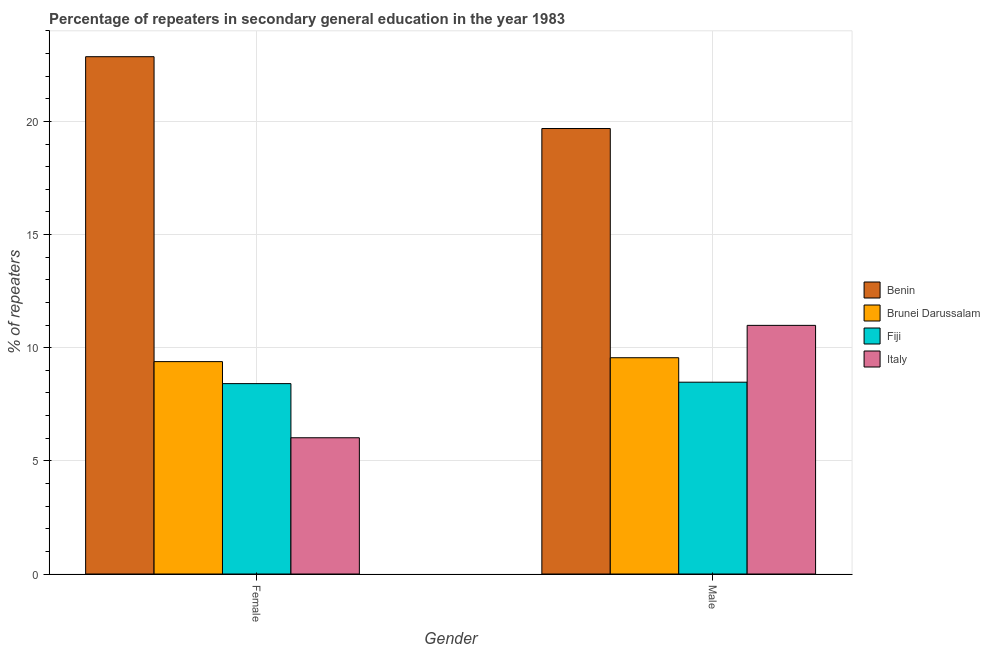Are the number of bars on each tick of the X-axis equal?
Provide a succinct answer. Yes. How many bars are there on the 1st tick from the right?
Ensure brevity in your answer.  4. What is the percentage of female repeaters in Brunei Darussalam?
Your answer should be compact. 9.38. Across all countries, what is the maximum percentage of female repeaters?
Your answer should be very brief. 22.86. Across all countries, what is the minimum percentage of male repeaters?
Offer a very short reply. 8.48. In which country was the percentage of male repeaters maximum?
Ensure brevity in your answer.  Benin. What is the total percentage of male repeaters in the graph?
Offer a terse response. 48.7. What is the difference between the percentage of male repeaters in Fiji and that in Benin?
Ensure brevity in your answer.  -11.21. What is the difference between the percentage of female repeaters in Benin and the percentage of male repeaters in Italy?
Keep it short and to the point. 11.87. What is the average percentage of female repeaters per country?
Make the answer very short. 11.67. What is the difference between the percentage of male repeaters and percentage of female repeaters in Fiji?
Offer a very short reply. 0.06. What is the ratio of the percentage of male repeaters in Benin to that in Brunei Darussalam?
Keep it short and to the point. 2.06. Is the percentage of male repeaters in Brunei Darussalam less than that in Italy?
Make the answer very short. Yes. What does the 1st bar from the left in Female represents?
Your answer should be compact. Benin. What does the 1st bar from the right in Female represents?
Give a very brief answer. Italy. Are all the bars in the graph horizontal?
Your answer should be very brief. No. Are the values on the major ticks of Y-axis written in scientific E-notation?
Provide a short and direct response. No. Where does the legend appear in the graph?
Provide a short and direct response. Center right. What is the title of the graph?
Provide a short and direct response. Percentage of repeaters in secondary general education in the year 1983. What is the label or title of the Y-axis?
Offer a very short reply. % of repeaters. What is the % of repeaters of Benin in Female?
Your response must be concise. 22.86. What is the % of repeaters of Brunei Darussalam in Female?
Keep it short and to the point. 9.38. What is the % of repeaters in Fiji in Female?
Offer a terse response. 8.41. What is the % of repeaters of Italy in Female?
Provide a succinct answer. 6.02. What is the % of repeaters of Benin in Male?
Give a very brief answer. 19.68. What is the % of repeaters in Brunei Darussalam in Male?
Your answer should be very brief. 9.56. What is the % of repeaters of Fiji in Male?
Make the answer very short. 8.48. What is the % of repeaters of Italy in Male?
Ensure brevity in your answer.  10.99. Across all Gender, what is the maximum % of repeaters in Benin?
Offer a very short reply. 22.86. Across all Gender, what is the maximum % of repeaters in Brunei Darussalam?
Ensure brevity in your answer.  9.56. Across all Gender, what is the maximum % of repeaters of Fiji?
Ensure brevity in your answer.  8.48. Across all Gender, what is the maximum % of repeaters in Italy?
Ensure brevity in your answer.  10.99. Across all Gender, what is the minimum % of repeaters in Benin?
Keep it short and to the point. 19.68. Across all Gender, what is the minimum % of repeaters in Brunei Darussalam?
Provide a short and direct response. 9.38. Across all Gender, what is the minimum % of repeaters in Fiji?
Your answer should be compact. 8.41. Across all Gender, what is the minimum % of repeaters of Italy?
Provide a succinct answer. 6.02. What is the total % of repeaters of Benin in the graph?
Keep it short and to the point. 42.54. What is the total % of repeaters of Brunei Darussalam in the graph?
Make the answer very short. 18.94. What is the total % of repeaters of Fiji in the graph?
Your answer should be compact. 16.89. What is the total % of repeaters of Italy in the graph?
Your response must be concise. 17.01. What is the difference between the % of repeaters in Benin in Female and that in Male?
Your response must be concise. 3.17. What is the difference between the % of repeaters in Brunei Darussalam in Female and that in Male?
Your answer should be very brief. -0.17. What is the difference between the % of repeaters in Fiji in Female and that in Male?
Your response must be concise. -0.06. What is the difference between the % of repeaters of Italy in Female and that in Male?
Offer a very short reply. -4.97. What is the difference between the % of repeaters in Benin in Female and the % of repeaters in Brunei Darussalam in Male?
Offer a terse response. 13.3. What is the difference between the % of repeaters in Benin in Female and the % of repeaters in Fiji in Male?
Make the answer very short. 14.38. What is the difference between the % of repeaters of Benin in Female and the % of repeaters of Italy in Male?
Make the answer very short. 11.87. What is the difference between the % of repeaters of Brunei Darussalam in Female and the % of repeaters of Fiji in Male?
Provide a short and direct response. 0.91. What is the difference between the % of repeaters in Brunei Darussalam in Female and the % of repeaters in Italy in Male?
Your answer should be compact. -1.6. What is the difference between the % of repeaters of Fiji in Female and the % of repeaters of Italy in Male?
Offer a terse response. -2.57. What is the average % of repeaters of Benin per Gender?
Your response must be concise. 21.27. What is the average % of repeaters in Brunei Darussalam per Gender?
Make the answer very short. 9.47. What is the average % of repeaters of Fiji per Gender?
Offer a very short reply. 8.44. What is the average % of repeaters of Italy per Gender?
Offer a terse response. 8.5. What is the difference between the % of repeaters of Benin and % of repeaters of Brunei Darussalam in Female?
Make the answer very short. 13.47. What is the difference between the % of repeaters in Benin and % of repeaters in Fiji in Female?
Provide a short and direct response. 14.45. What is the difference between the % of repeaters in Benin and % of repeaters in Italy in Female?
Your answer should be very brief. 16.84. What is the difference between the % of repeaters in Brunei Darussalam and % of repeaters in Fiji in Female?
Provide a succinct answer. 0.97. What is the difference between the % of repeaters of Brunei Darussalam and % of repeaters of Italy in Female?
Provide a short and direct response. 3.36. What is the difference between the % of repeaters in Fiji and % of repeaters in Italy in Female?
Provide a succinct answer. 2.39. What is the difference between the % of repeaters in Benin and % of repeaters in Brunei Darussalam in Male?
Your response must be concise. 10.13. What is the difference between the % of repeaters in Benin and % of repeaters in Fiji in Male?
Provide a short and direct response. 11.21. What is the difference between the % of repeaters in Benin and % of repeaters in Italy in Male?
Keep it short and to the point. 8.7. What is the difference between the % of repeaters of Brunei Darussalam and % of repeaters of Fiji in Male?
Offer a very short reply. 1.08. What is the difference between the % of repeaters in Brunei Darussalam and % of repeaters in Italy in Male?
Your answer should be compact. -1.43. What is the difference between the % of repeaters of Fiji and % of repeaters of Italy in Male?
Keep it short and to the point. -2.51. What is the ratio of the % of repeaters of Benin in Female to that in Male?
Ensure brevity in your answer.  1.16. What is the ratio of the % of repeaters of Italy in Female to that in Male?
Your answer should be compact. 0.55. What is the difference between the highest and the second highest % of repeaters in Benin?
Your answer should be very brief. 3.17. What is the difference between the highest and the second highest % of repeaters of Brunei Darussalam?
Keep it short and to the point. 0.17. What is the difference between the highest and the second highest % of repeaters in Fiji?
Your response must be concise. 0.06. What is the difference between the highest and the second highest % of repeaters of Italy?
Your answer should be compact. 4.97. What is the difference between the highest and the lowest % of repeaters of Benin?
Give a very brief answer. 3.17. What is the difference between the highest and the lowest % of repeaters of Brunei Darussalam?
Your answer should be very brief. 0.17. What is the difference between the highest and the lowest % of repeaters of Fiji?
Your response must be concise. 0.06. What is the difference between the highest and the lowest % of repeaters of Italy?
Offer a terse response. 4.97. 